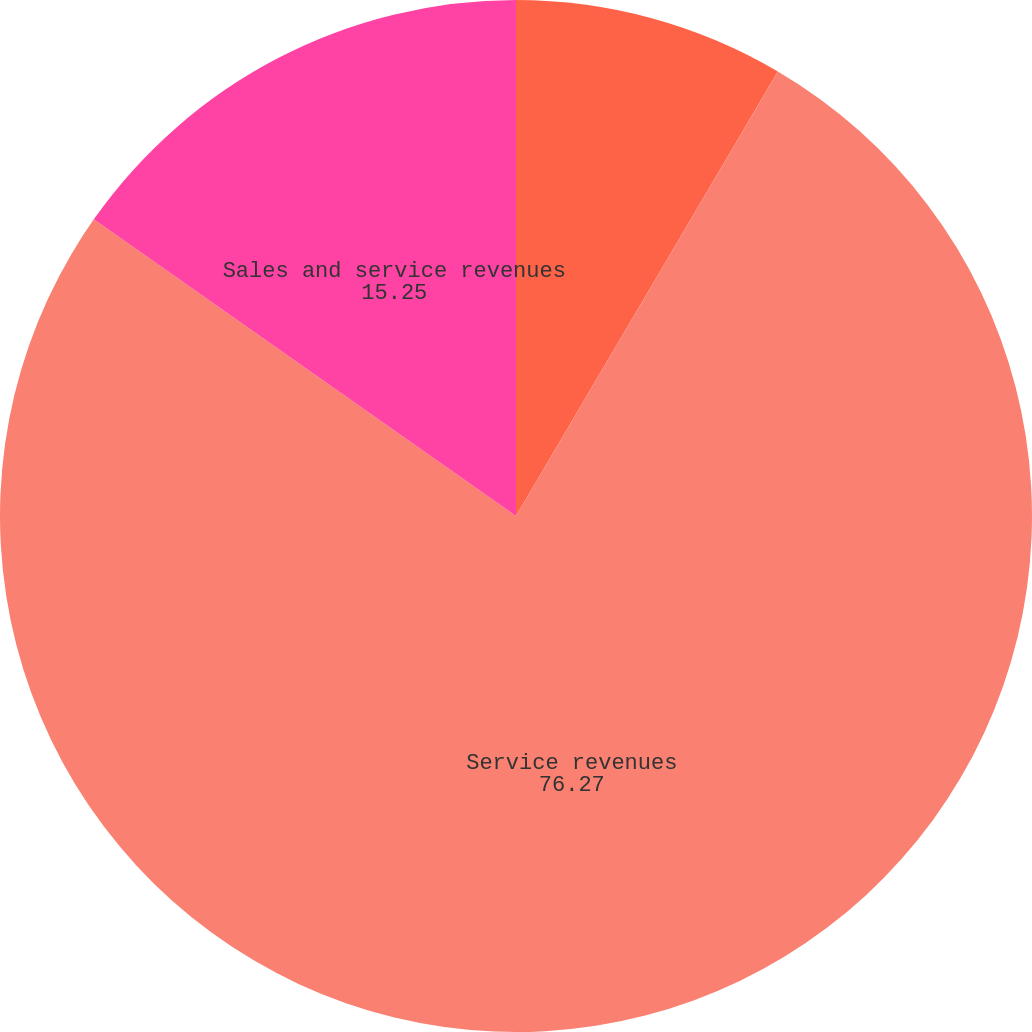Convert chart. <chart><loc_0><loc_0><loc_500><loc_500><pie_chart><fcel>Product sales<fcel>Service revenues<fcel>Sales and service revenues<nl><fcel>8.47%<fcel>76.27%<fcel>15.25%<nl></chart> 